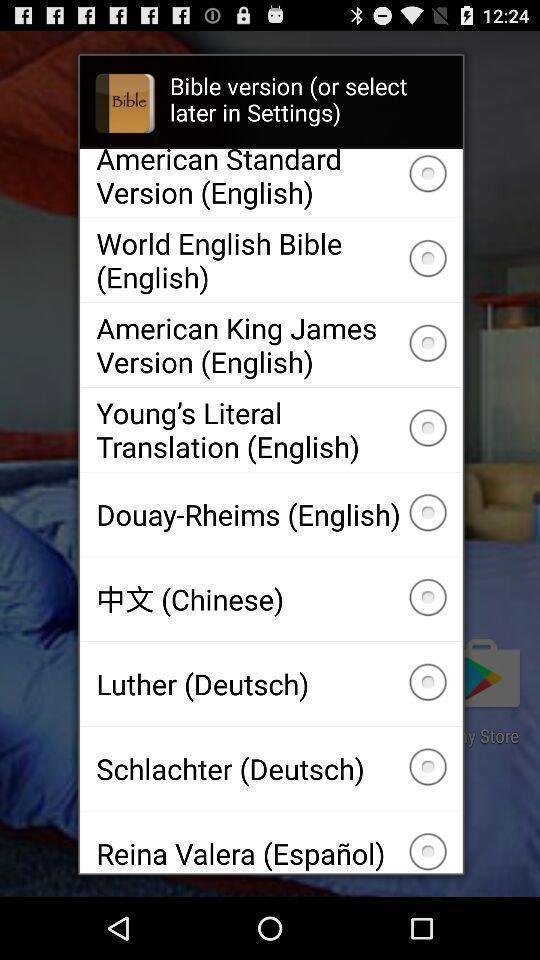Describe the content in this image. Pop-up showing several recordings in bible. 